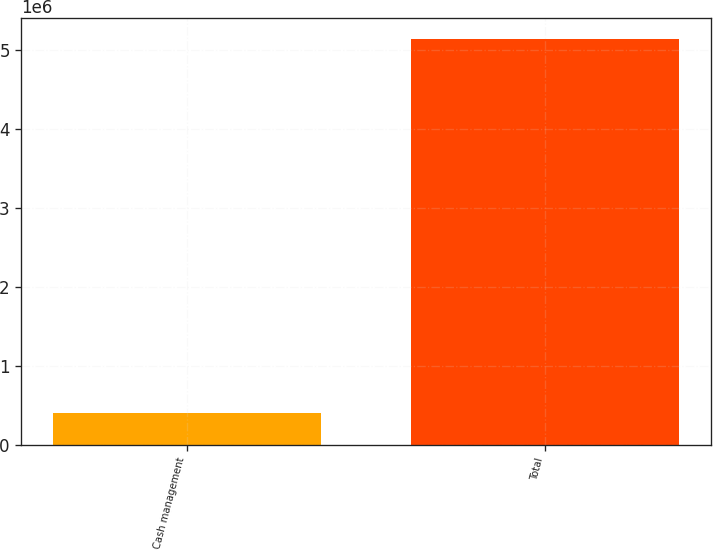<chart> <loc_0><loc_0><loc_500><loc_500><bar_chart><fcel>Cash management<fcel>Total<nl><fcel>403584<fcel>5.14785e+06<nl></chart> 